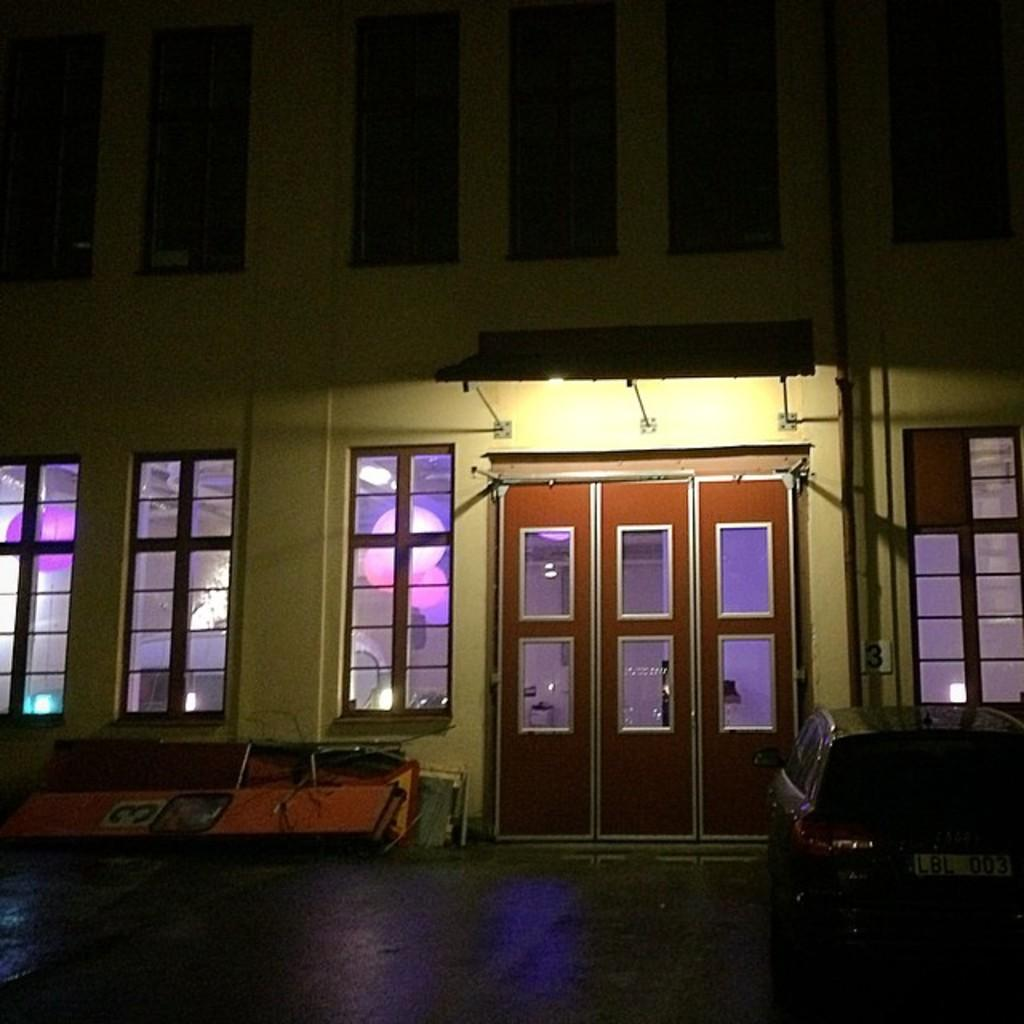What is the main subject of the image? The main subject of the image is a vehicle. Can you describe the position of the vehicle in the image? The vehicle is on the ground in the image. What can be seen in the background of the image? There is a building in the background of the image. What type of sand can be seen in the image? There is no sand present in the image. Can you tell me how many vases are visible in the image? There are no vases present in the image. 